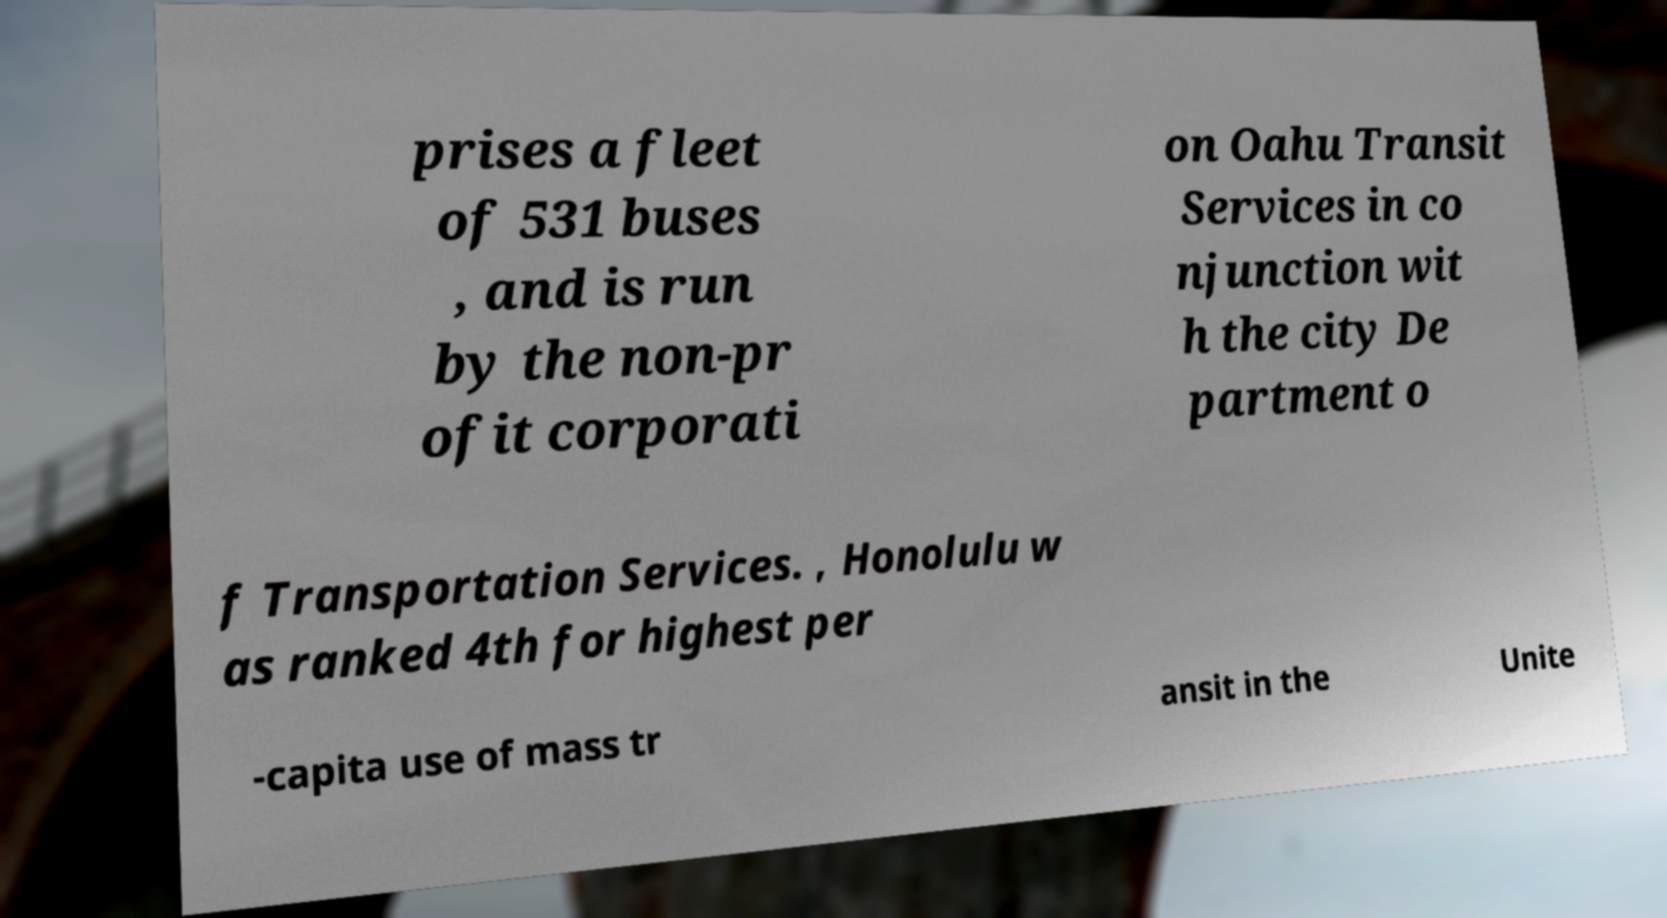Please read and relay the text visible in this image. What does it say? prises a fleet of 531 buses , and is run by the non-pr ofit corporati on Oahu Transit Services in co njunction wit h the city De partment o f Transportation Services. , Honolulu w as ranked 4th for highest per -capita use of mass tr ansit in the Unite 